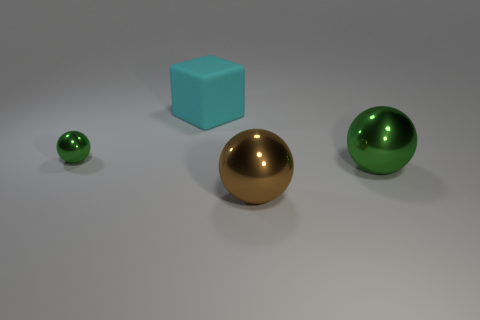What color is the other metal thing that is the same size as the brown metallic thing?
Your answer should be compact. Green. What number of blocks are either brown metal objects or large metal objects?
Your response must be concise. 0. Does the big brown object have the same shape as the metal object left of the large cube?
Provide a short and direct response. Yes. What number of brown metal objects are the same size as the cyan cube?
Provide a succinct answer. 1. Do the green metallic thing that is right of the tiny green ball and the large thing behind the small shiny object have the same shape?
Keep it short and to the point. No. The shiny sphere in front of the green ball that is right of the small object is what color?
Offer a very short reply. Brown. There is another big object that is the same shape as the large green metallic object; what is its color?
Offer a terse response. Brown. Is there any other thing that is the same material as the cyan cube?
Offer a very short reply. No. What is the size of the other green thing that is the same shape as the small green metallic object?
Your answer should be compact. Large. What is the material of the large object behind the big green sphere?
Provide a succinct answer. Rubber. 